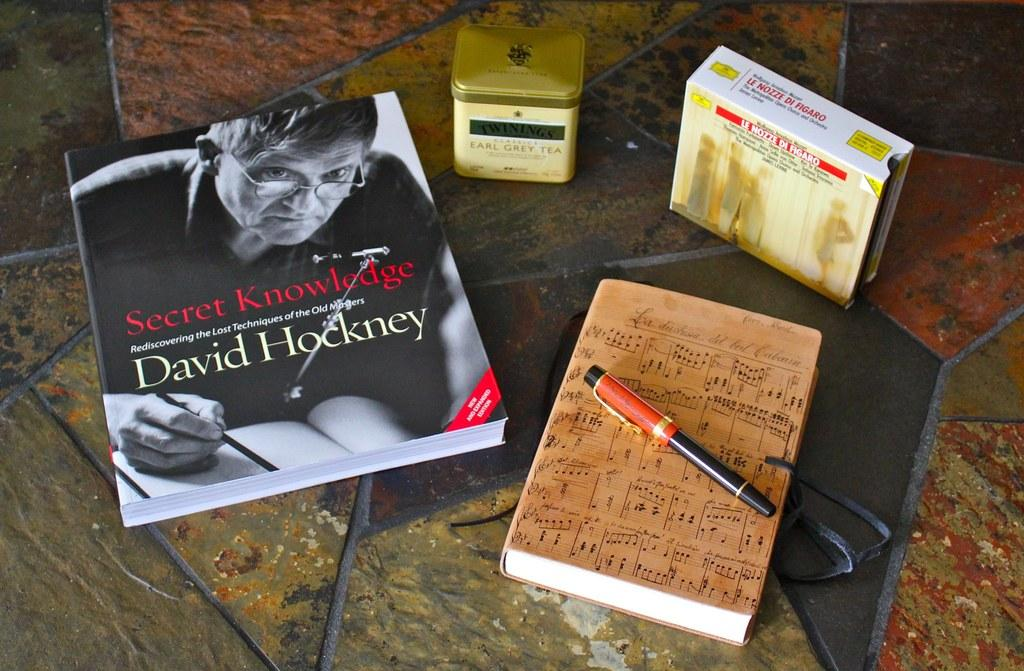What objects are on the floor in the image? There are books, a container, and a box on the floor. What is the pen doing in the image? The pen is on a book. What can be seen on the book with the pen? There is a person depicted on the book. How many balls are rolling on the floor in the image? There are no balls present in the image. What type of beetle can be seen crawling on the books in the image? There are no beetles present in the image. 